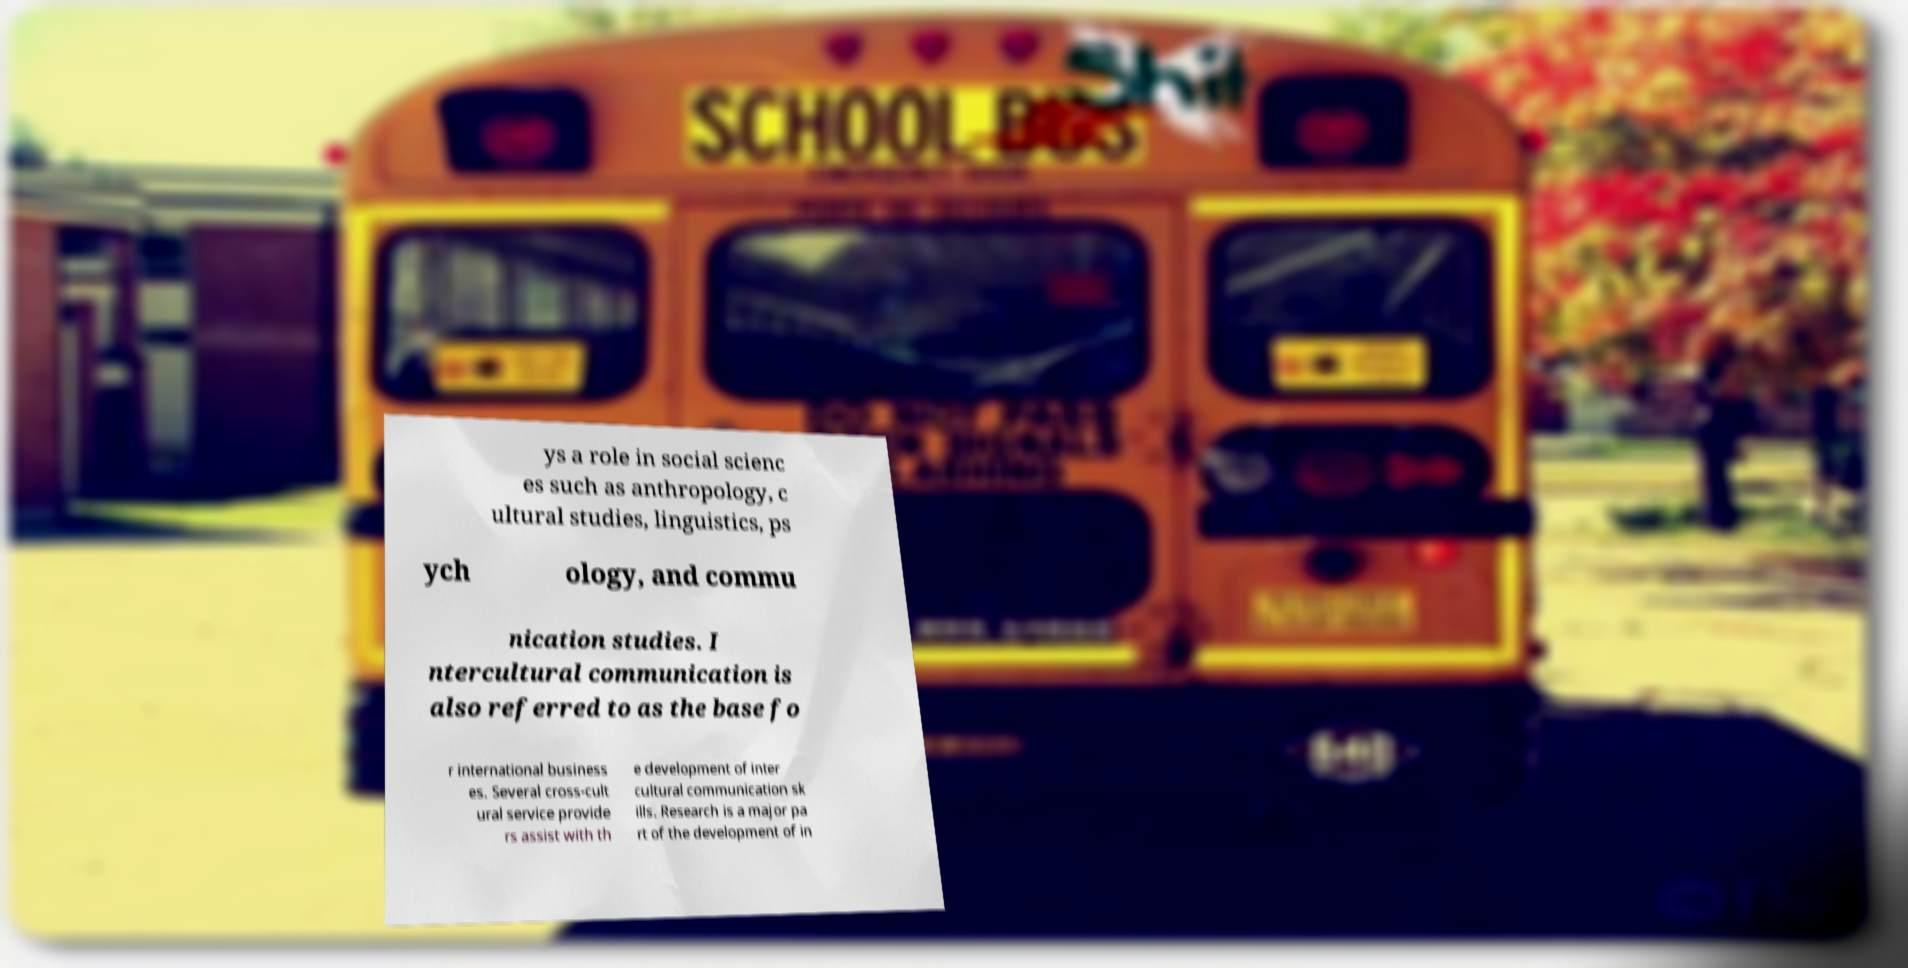Could you extract and type out the text from this image? ys a role in social scienc es such as anthropology, c ultural studies, linguistics, ps ych ology, and commu nication studies. I ntercultural communication is also referred to as the base fo r international business es. Several cross-cult ural service provide rs assist with th e development of inter cultural communication sk ills. Research is a major pa rt of the development of in 